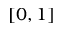Convert formula to latex. <formula><loc_0><loc_0><loc_500><loc_500>[ 0 , 1 ]</formula> 